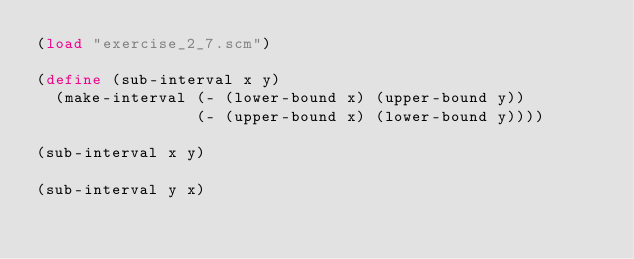Convert code to text. <code><loc_0><loc_0><loc_500><loc_500><_Scheme_>(load "exercise_2_7.scm")

(define (sub-interval x y)
  (make-interval (- (lower-bound x) (upper-bound y))
                 (- (upper-bound x) (lower-bound y))))

(sub-interval x y)

(sub-interval y x)</code> 